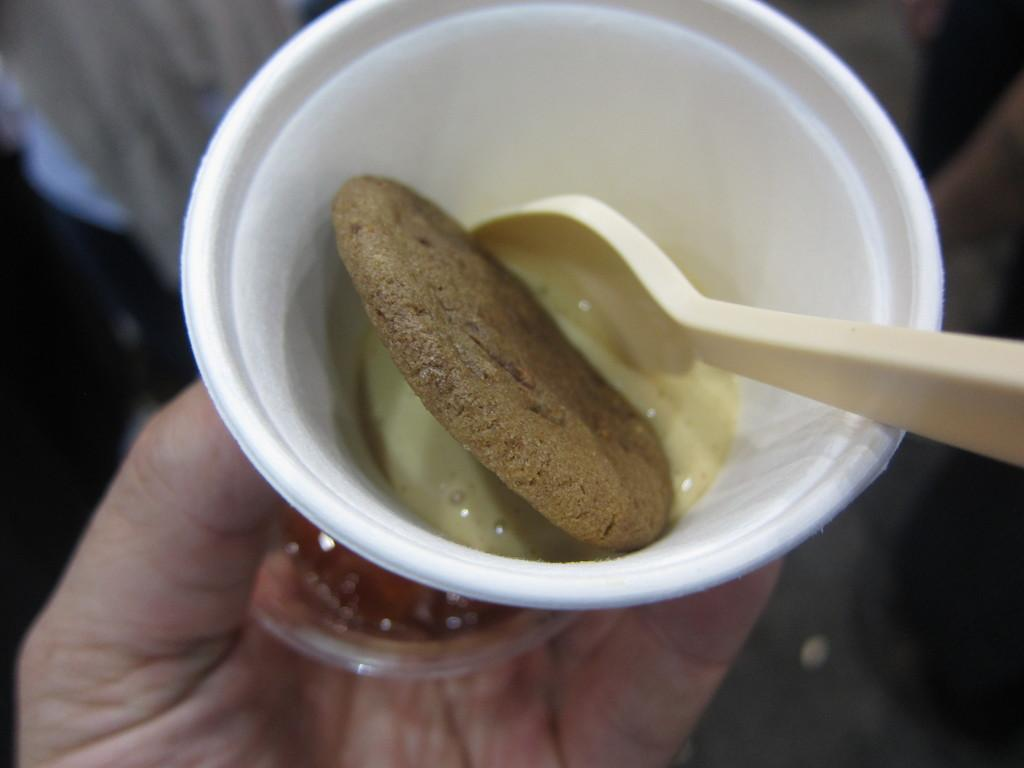Who or what is the main subject of the subject in the image? There is a person in the image. What is the person holding in the image? The person is holding a cup. What is inside the cup that the person is holding? The cup contains a biscuit, spoon, and a desert. Can you describe the background of the image? The background of the image is blurry. What type of pen can be seen in the person's hand in the image? There is no pen visible in the person's hand in the image; they are holding a cup. Can you describe the fangs of the person in the image? There are no fangs present on the person in the image. 